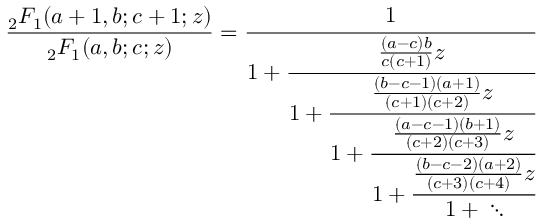Convert formula to latex. <formula><loc_0><loc_0><loc_500><loc_500>{ \frac _ { 2 } F _ { 1 } ( a + 1 , b ; c + 1 ; z ) } _ { 2 } F _ { 1 } ( a , b ; c ; z ) } } = { \cfrac { 1 } { 1 + { \cfrac { { \frac { ( a - c ) b } { c ( c + 1 ) } } z } { 1 + { \cfrac { { \frac { ( b - c - 1 ) ( a + 1 ) } { ( c + 1 ) ( c + 2 ) } } z } { 1 + { \cfrac { { \frac { ( a - c - 1 ) ( b + 1 ) } { ( c + 2 ) ( c + 3 ) } } z } { 1 + { \cfrac { { \frac { ( b - c - 2 ) ( a + 2 ) } { ( c + 3 ) ( c + 4 ) } } z } { 1 \ddots } } } } } } } } } }</formula> 